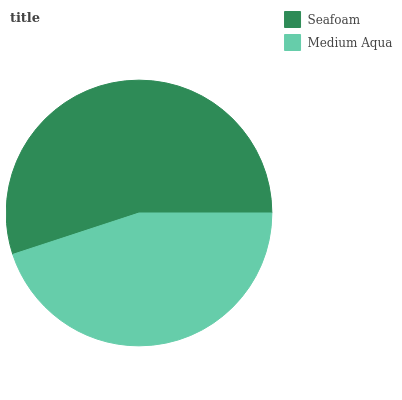Is Medium Aqua the minimum?
Answer yes or no. Yes. Is Seafoam the maximum?
Answer yes or no. Yes. Is Medium Aqua the maximum?
Answer yes or no. No. Is Seafoam greater than Medium Aqua?
Answer yes or no. Yes. Is Medium Aqua less than Seafoam?
Answer yes or no. Yes. Is Medium Aqua greater than Seafoam?
Answer yes or no. No. Is Seafoam less than Medium Aqua?
Answer yes or no. No. Is Seafoam the high median?
Answer yes or no. Yes. Is Medium Aqua the low median?
Answer yes or no. Yes. Is Medium Aqua the high median?
Answer yes or no. No. Is Seafoam the low median?
Answer yes or no. No. 